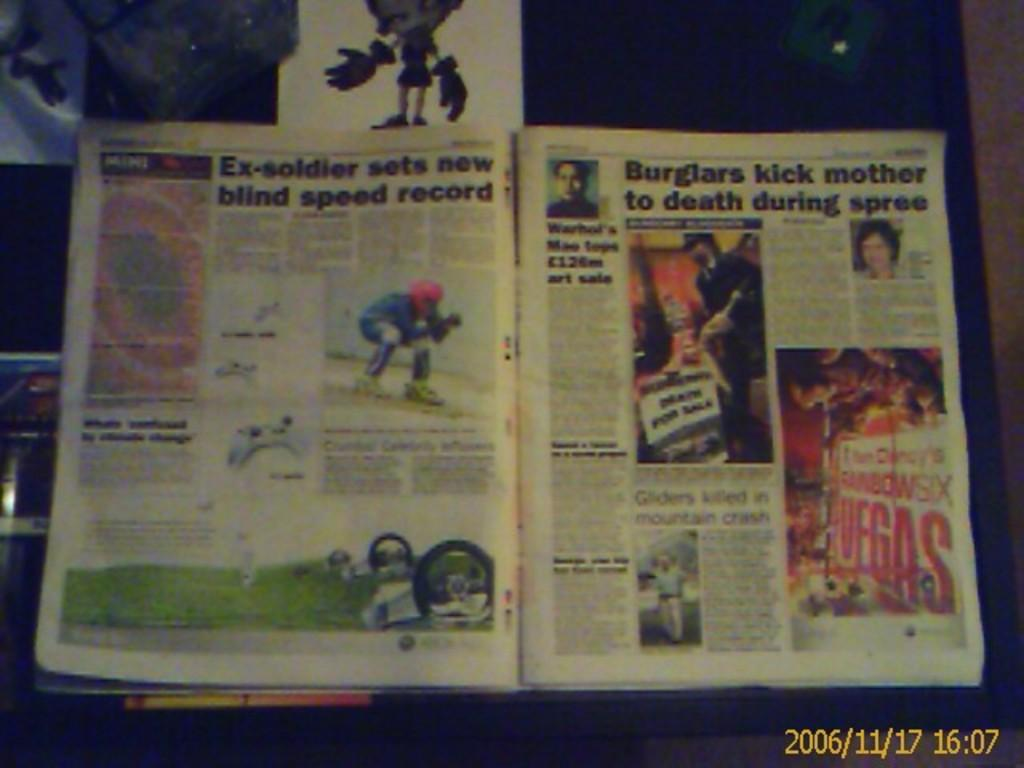<image>
Describe the image concisely. A page of a magazine with the title "Ex-soldier sets new blind speed record" on it. 